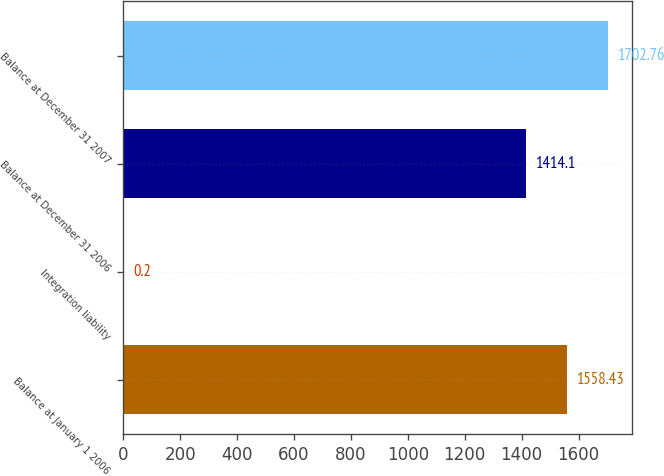<chart> <loc_0><loc_0><loc_500><loc_500><bar_chart><fcel>Balance at January 1 2006<fcel>Integration liability<fcel>Balance at December 31 2006<fcel>Balance at December 31 2007<nl><fcel>1558.43<fcel>0.2<fcel>1414.1<fcel>1702.76<nl></chart> 